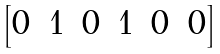Convert formula to latex. <formula><loc_0><loc_0><loc_500><loc_500>\begin{bmatrix} 0 & 1 & 0 & 1 & 0 & 0 \end{bmatrix}</formula> 